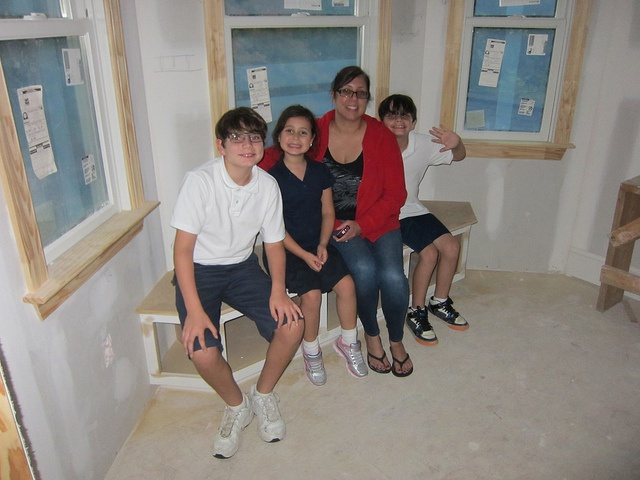Describe the objects in this image and their specific colors. I can see people in gray, lightgray, black, and darkgray tones, people in gray, black, maroon, and brown tones, people in gray, black, and darkgray tones, bench in gray and darkgray tones, and people in gray, black, and darkgray tones in this image. 